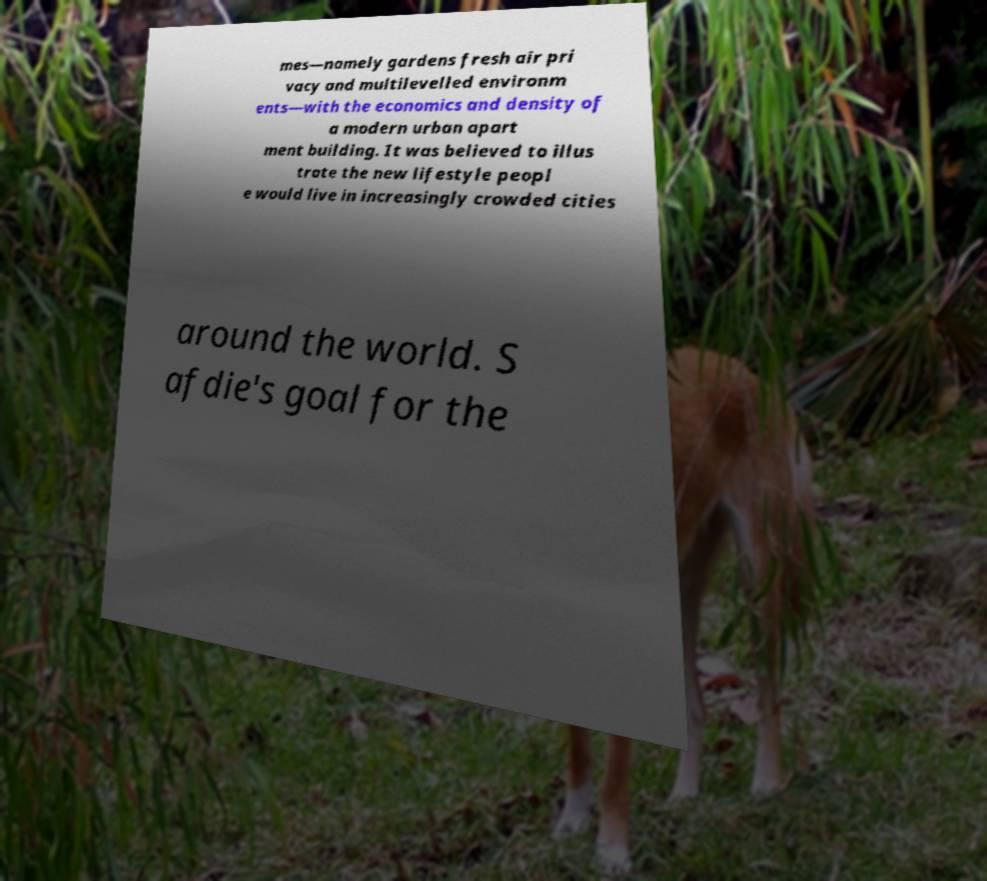I need the written content from this picture converted into text. Can you do that? mes—namely gardens fresh air pri vacy and multilevelled environm ents—with the economics and density of a modern urban apart ment building. It was believed to illus trate the new lifestyle peopl e would live in increasingly crowded cities around the world. S afdie's goal for the 